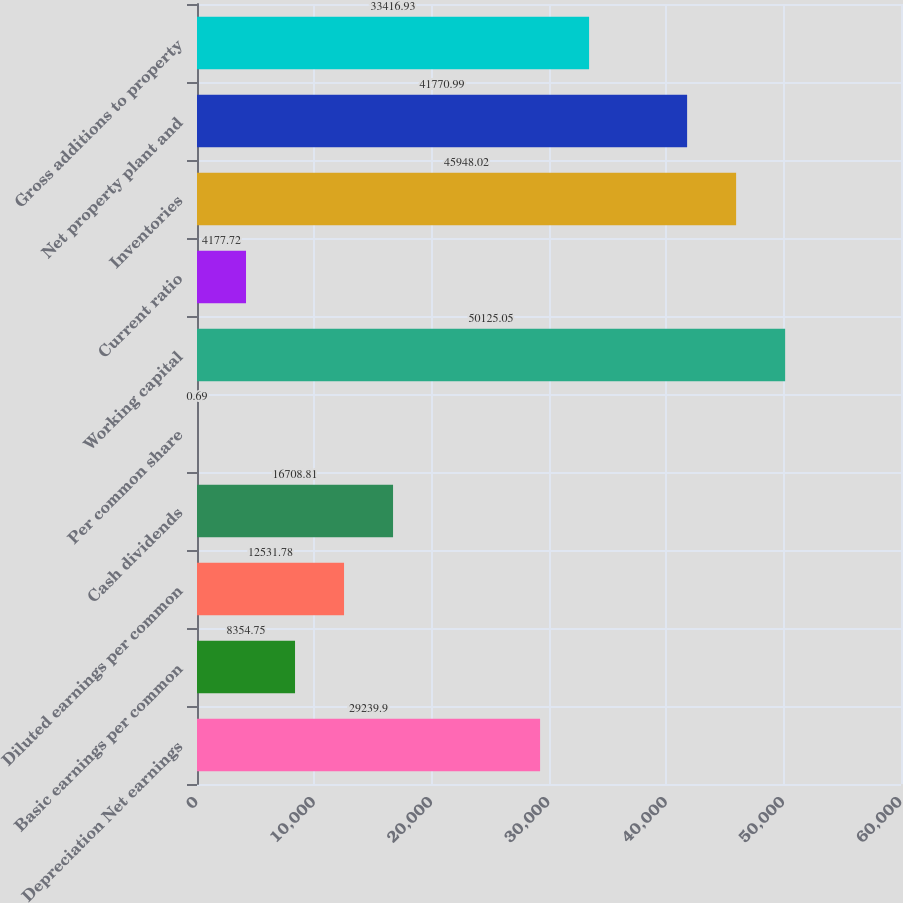Convert chart to OTSL. <chart><loc_0><loc_0><loc_500><loc_500><bar_chart><fcel>Depreciation Net earnings<fcel>Basic earnings per common<fcel>Diluted earnings per common<fcel>Cash dividends<fcel>Per common share<fcel>Working capital<fcel>Current ratio<fcel>Inventories<fcel>Net property plant and<fcel>Gross additions to property<nl><fcel>29239.9<fcel>8354.75<fcel>12531.8<fcel>16708.8<fcel>0.69<fcel>50125.1<fcel>4177.72<fcel>45948<fcel>41771<fcel>33416.9<nl></chart> 